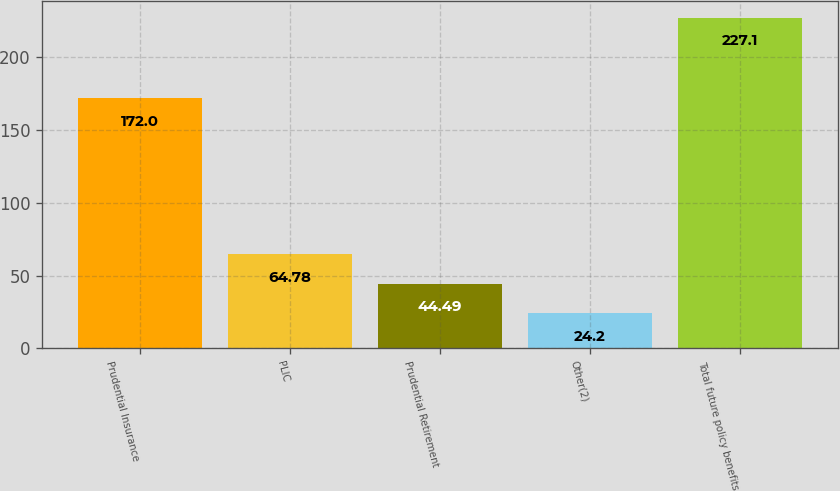<chart> <loc_0><loc_0><loc_500><loc_500><bar_chart><fcel>Prudential Insurance<fcel>PLIC<fcel>Prudential Retirement<fcel>Other(2)<fcel>Total future policy benefits<nl><fcel>172<fcel>64.78<fcel>44.49<fcel>24.2<fcel>227.1<nl></chart> 